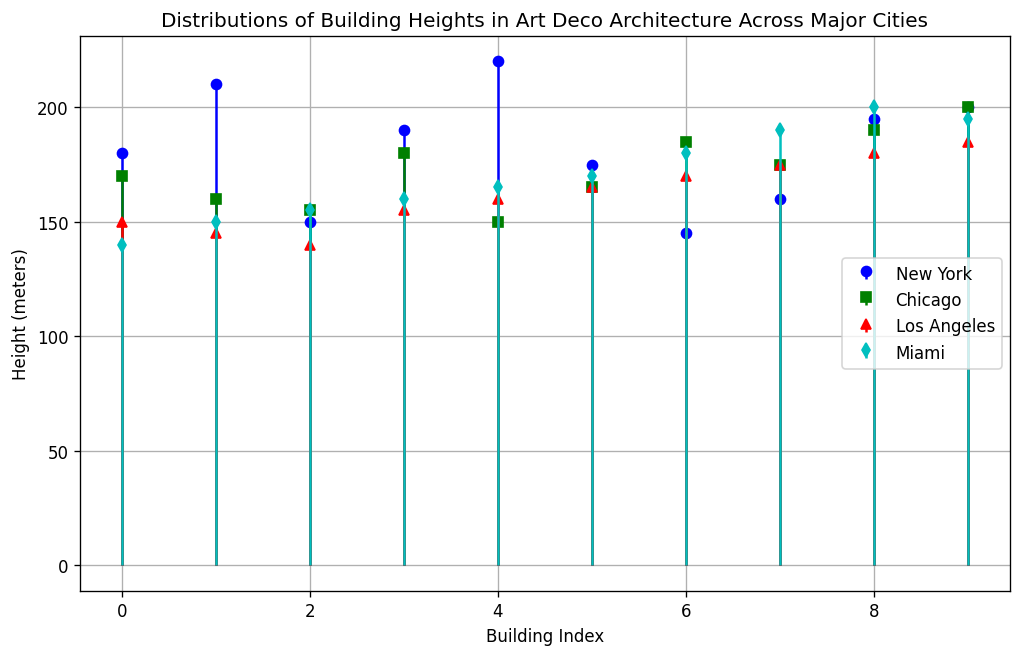Which city has the tallest building? By looking at the plot, identify the city assigned with the color and marker that marks the tallest building. Check which one reaches 220 meters.
Answer: New York How many buildings in New York are taller than 200 meters? In the stem plot, find the markers representing New York buildings at heights above 200 meters. Count them.
Answer: 2 Which city has the smallest range of building heights? Determine the range (difference between the highest and lowest building heights) for each city by looking at the stem plot's highest and lowest markers for each city. Compare the ranges.
Answer: Los Angeles Compare the median building heights of New York and Los Angeles. Which city has a higher median? Identify the middle building height values for both cities by arranging their heights in ascending order from the plot data.
Answer: New York Which city displays the most uniform distribution of building heights? Look at the plots and determine the city where the heights are most evenly spread without large gaps or clusters.
Answer: Miami How does the tallest building in Chicago compare to the tallest building in Miami? Identify the tallest buildings in both cities from the plot and compare their heights. Chicago's tallest is 200 meters while Miami's tallest is 200 meters.
Answer: Equal What is the difference in the total number of buildings plotted for New York and Los Angeles? Count the number of stems (buildings) for both cities from the plot. Subtract the count of Los Angeles from New York.
Answer: 0 What is the average building height for New York? Sum up the height values for New York buildings visible in the plot and divide by the number of buildings.
Answer: 182.5 meters Which city's plot shows the highest density of buildings in the height range of 160 to 180 meters? Examine the number of markers in the 160 to 180 meters height range for each city.
Answer: Chicago Is there any overlap in building heights between New York and Miami? Identify if any building heights in the plots for New York match with those from Miami. Both cities span a similar height range.
Answer: Yes 